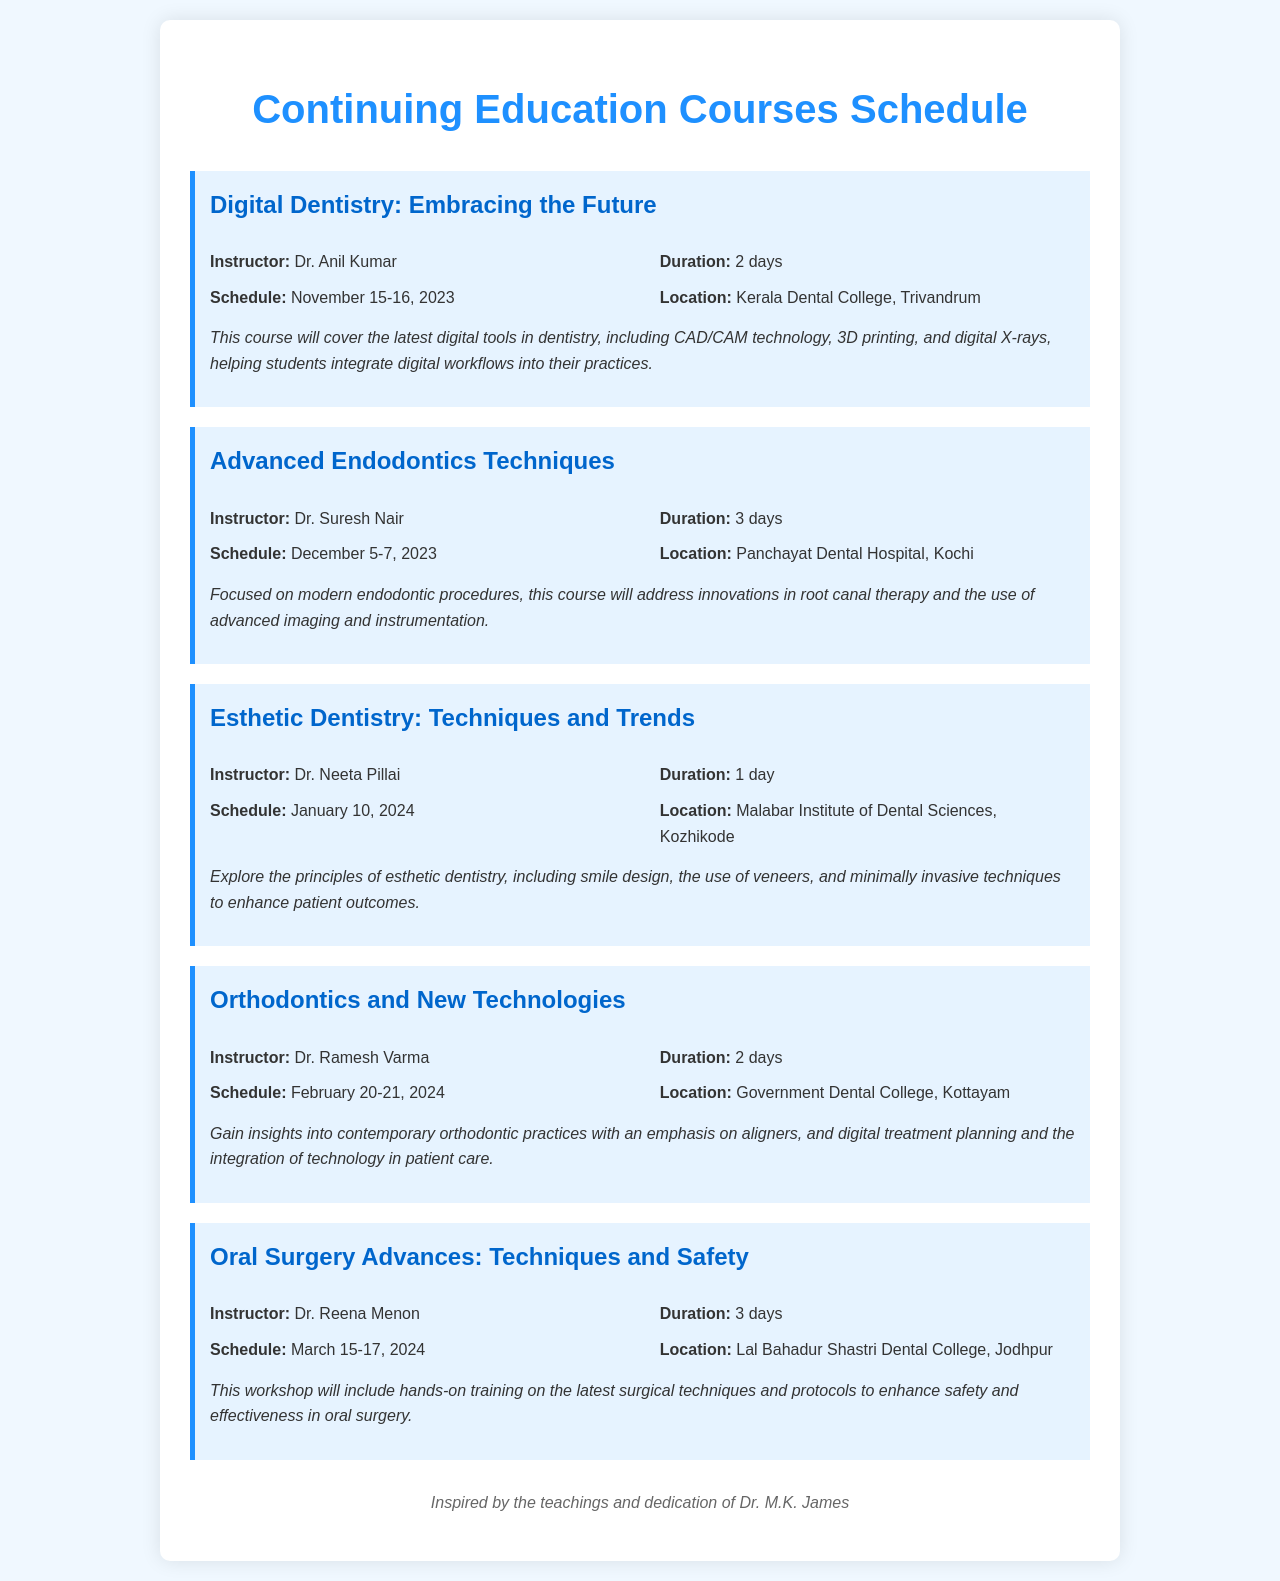What is the title of the first course? The title of the first course is listed at the beginning of the course section.
Answer: Digital Dentistry: Embracing the Future Who is the instructor for the Advanced Endodontics Techniques course? The instructor's name is specified in the course details.
Answer: Dr. Suresh Nair How many days is the Esthetic Dentistry course? The duration of the course is mentioned in the course info.
Answer: 1 day When is the Oral Surgery Advances course scheduled? The schedule is provided in the course details as a date range.
Answer: March 15-17, 2024 What is the location of the Orthodontics and New Technologies course? The location is specified in the course info section.
Answer: Government Dental College, Kottayam Which course has the longest duration? The duration of each course is compared to find the longest one.
Answer: Advanced Endodontics Techniques What is the focus of the Digital Dentistry course? The description outlines the main topics and tools covered in the course.
Answer: Latest digital tools in dentistry Which institution is hosting the Esthetic Dentistry course? The hosting institution is mentioned in the location part of the course details.
Answer: Malabar Institute of Dental Sciences, Kozhikode 